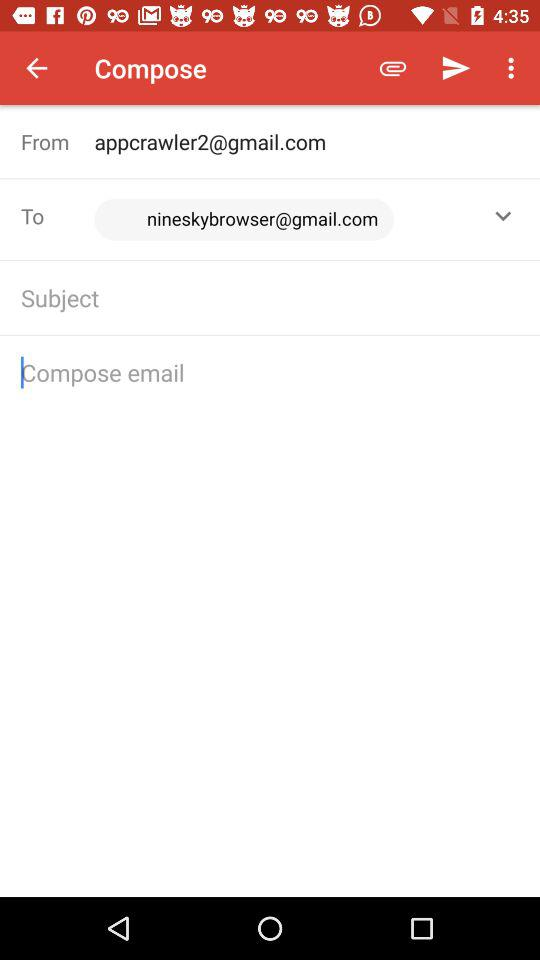How many text fields are there in this email compose screen?
Answer the question using a single word or phrase. 3 